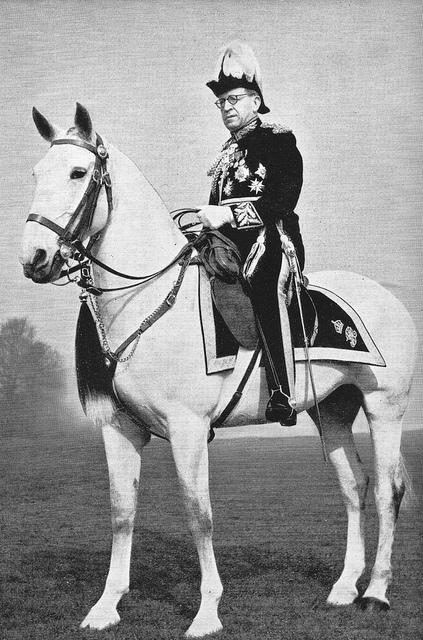What did this man serve in? Please explain your reasoning. military. The man is riding a horse and wearing a uniform that looks like a soldier's uniform. 